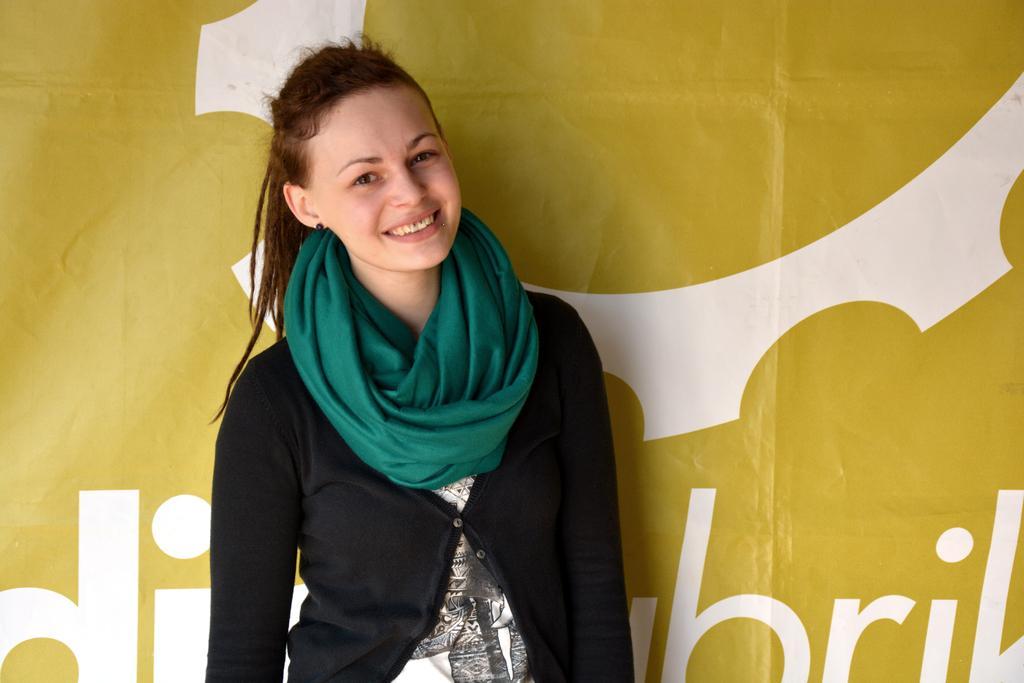Describe this image in one or two sentences. In the middle of the image a girl is standing and she is with a smiling face. In the background there is a banner with a text on it. 